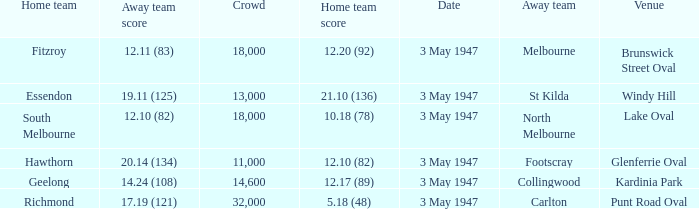Which venue did the away team score 12.10 (82)? Lake Oval. 